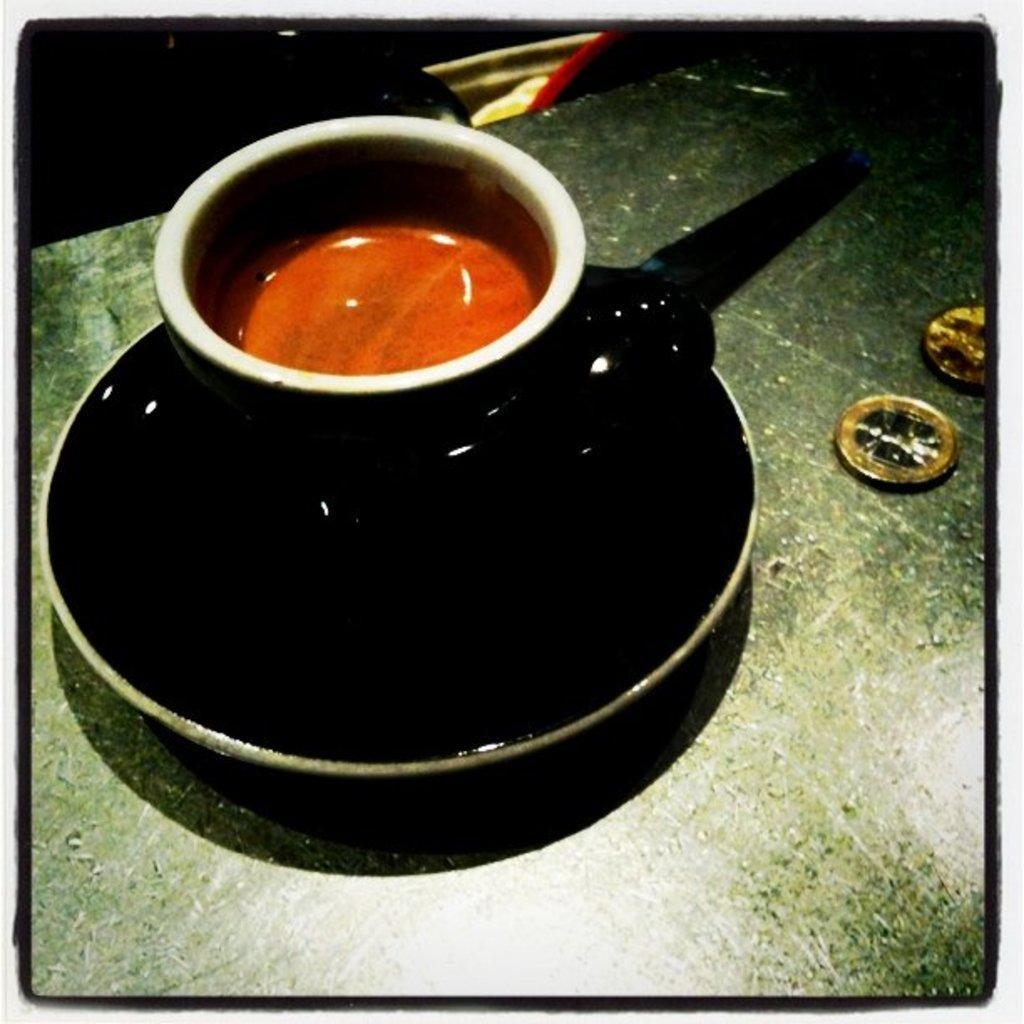Describe this image in one or two sentences. In this image we can see a cup in a saucer which is placed on the surface. We can also see some coins beside them. 